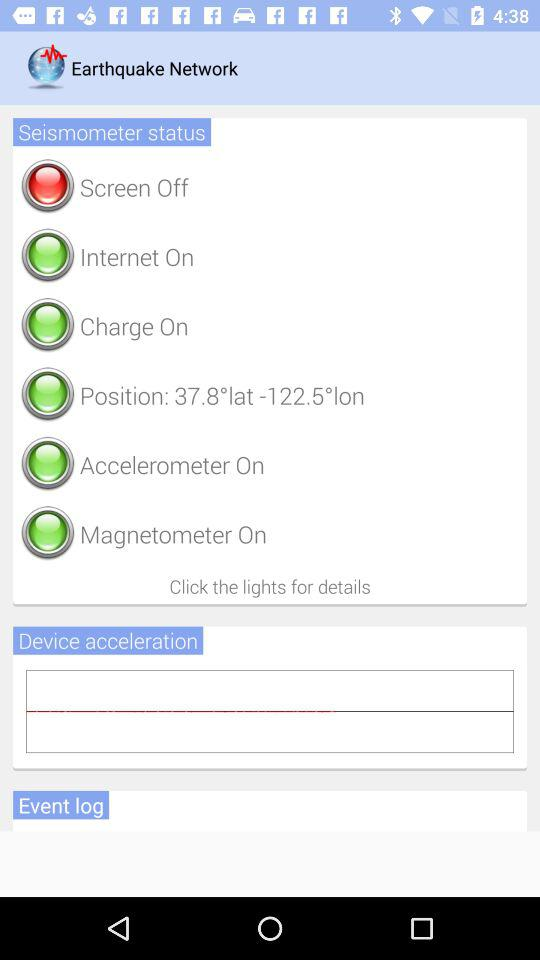What is the application name? The application name is "Earthquake Network". 